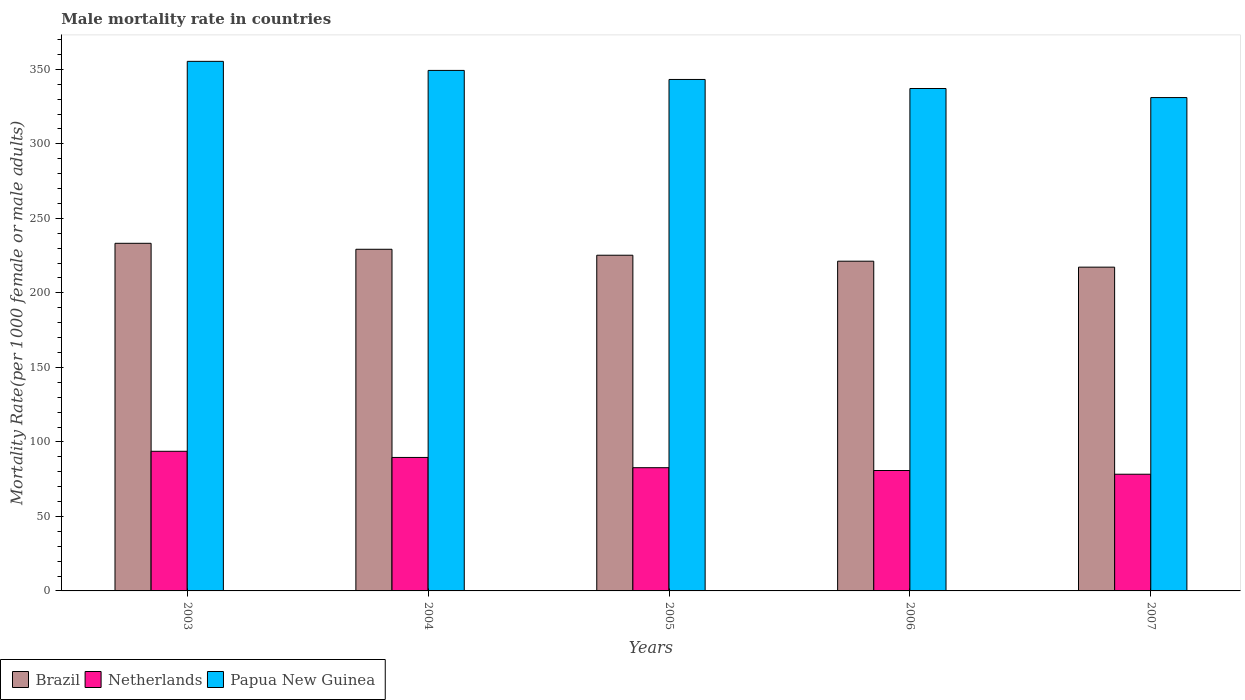How many bars are there on the 1st tick from the right?
Provide a short and direct response. 3. What is the label of the 1st group of bars from the left?
Give a very brief answer. 2003. What is the male mortality rate in Papua New Guinea in 2005?
Your answer should be very brief. 343.22. Across all years, what is the maximum male mortality rate in Papua New Guinea?
Provide a succinct answer. 355.37. Across all years, what is the minimum male mortality rate in Papua New Guinea?
Ensure brevity in your answer.  331.07. In which year was the male mortality rate in Papua New Guinea maximum?
Keep it short and to the point. 2003. What is the total male mortality rate in Netherlands in the graph?
Your response must be concise. 425.08. What is the difference between the male mortality rate in Brazil in 2004 and that in 2006?
Provide a short and direct response. 8. What is the difference between the male mortality rate in Papua New Guinea in 2007 and the male mortality rate in Brazil in 2006?
Your answer should be compact. 109.8. What is the average male mortality rate in Netherlands per year?
Provide a short and direct response. 85.02. In the year 2005, what is the difference between the male mortality rate in Netherlands and male mortality rate in Papua New Guinea?
Provide a succinct answer. -260.53. In how many years, is the male mortality rate in Papua New Guinea greater than 60?
Give a very brief answer. 5. What is the ratio of the male mortality rate in Brazil in 2003 to that in 2004?
Provide a succinct answer. 1.02. Is the male mortality rate in Brazil in 2003 less than that in 2005?
Offer a terse response. No. What is the difference between the highest and the second highest male mortality rate in Netherlands?
Make the answer very short. 4.14. What is the difference between the highest and the lowest male mortality rate in Netherlands?
Ensure brevity in your answer.  15.39. In how many years, is the male mortality rate in Netherlands greater than the average male mortality rate in Netherlands taken over all years?
Your response must be concise. 2. What does the 3rd bar from the left in 2004 represents?
Provide a short and direct response. Papua New Guinea. What does the 1st bar from the right in 2005 represents?
Offer a terse response. Papua New Guinea. Is it the case that in every year, the sum of the male mortality rate in Netherlands and male mortality rate in Brazil is greater than the male mortality rate in Papua New Guinea?
Provide a short and direct response. No. Are all the bars in the graph horizontal?
Give a very brief answer. No. How many years are there in the graph?
Your answer should be very brief. 5. What is the difference between two consecutive major ticks on the Y-axis?
Your answer should be compact. 50. Does the graph contain any zero values?
Ensure brevity in your answer.  No. Does the graph contain grids?
Provide a succinct answer. No. Where does the legend appear in the graph?
Your answer should be compact. Bottom left. What is the title of the graph?
Your response must be concise. Male mortality rate in countries. What is the label or title of the X-axis?
Provide a short and direct response. Years. What is the label or title of the Y-axis?
Keep it short and to the point. Mortality Rate(per 1000 female or male adults). What is the Mortality Rate(per 1000 female or male adults) of Brazil in 2003?
Ensure brevity in your answer.  233.27. What is the Mortality Rate(per 1000 female or male adults) of Netherlands in 2003?
Make the answer very short. 93.7. What is the Mortality Rate(per 1000 female or male adults) of Papua New Guinea in 2003?
Provide a succinct answer. 355.37. What is the Mortality Rate(per 1000 female or male adults) in Brazil in 2004?
Provide a short and direct response. 229.27. What is the Mortality Rate(per 1000 female or male adults) in Netherlands in 2004?
Give a very brief answer. 89.57. What is the Mortality Rate(per 1000 female or male adults) of Papua New Guinea in 2004?
Your response must be concise. 349.3. What is the Mortality Rate(per 1000 female or male adults) of Brazil in 2005?
Provide a short and direct response. 225.27. What is the Mortality Rate(per 1000 female or male adults) of Netherlands in 2005?
Offer a very short reply. 82.69. What is the Mortality Rate(per 1000 female or male adults) of Papua New Guinea in 2005?
Provide a short and direct response. 343.22. What is the Mortality Rate(per 1000 female or male adults) of Brazil in 2006?
Your response must be concise. 221.27. What is the Mortality Rate(per 1000 female or male adults) in Netherlands in 2006?
Your answer should be very brief. 80.8. What is the Mortality Rate(per 1000 female or male adults) of Papua New Guinea in 2006?
Offer a terse response. 337.14. What is the Mortality Rate(per 1000 female or male adults) of Brazil in 2007?
Your answer should be very brief. 217.27. What is the Mortality Rate(per 1000 female or male adults) of Netherlands in 2007?
Your answer should be very brief. 78.31. What is the Mortality Rate(per 1000 female or male adults) in Papua New Guinea in 2007?
Provide a short and direct response. 331.07. Across all years, what is the maximum Mortality Rate(per 1000 female or male adults) in Brazil?
Offer a terse response. 233.27. Across all years, what is the maximum Mortality Rate(per 1000 female or male adults) of Netherlands?
Your response must be concise. 93.7. Across all years, what is the maximum Mortality Rate(per 1000 female or male adults) in Papua New Guinea?
Your response must be concise. 355.37. Across all years, what is the minimum Mortality Rate(per 1000 female or male adults) of Brazil?
Offer a very short reply. 217.27. Across all years, what is the minimum Mortality Rate(per 1000 female or male adults) of Netherlands?
Give a very brief answer. 78.31. Across all years, what is the minimum Mortality Rate(per 1000 female or male adults) of Papua New Guinea?
Provide a succinct answer. 331.07. What is the total Mortality Rate(per 1000 female or male adults) of Brazil in the graph?
Provide a short and direct response. 1126.34. What is the total Mortality Rate(per 1000 female or male adults) in Netherlands in the graph?
Keep it short and to the point. 425.08. What is the total Mortality Rate(per 1000 female or male adults) in Papua New Guinea in the graph?
Provide a short and direct response. 1716.1. What is the difference between the Mortality Rate(per 1000 female or male adults) of Brazil in 2003 and that in 2004?
Your answer should be very brief. 4. What is the difference between the Mortality Rate(per 1000 female or male adults) in Netherlands in 2003 and that in 2004?
Provide a succinct answer. 4.14. What is the difference between the Mortality Rate(per 1000 female or male adults) in Papua New Guinea in 2003 and that in 2004?
Provide a succinct answer. 6.08. What is the difference between the Mortality Rate(per 1000 female or male adults) in Brazil in 2003 and that in 2005?
Your response must be concise. 8. What is the difference between the Mortality Rate(per 1000 female or male adults) in Netherlands in 2003 and that in 2005?
Provide a succinct answer. 11.01. What is the difference between the Mortality Rate(per 1000 female or male adults) of Papua New Guinea in 2003 and that in 2005?
Offer a very short reply. 12.15. What is the difference between the Mortality Rate(per 1000 female or male adults) in Brazil in 2003 and that in 2006?
Make the answer very short. 12. What is the difference between the Mortality Rate(per 1000 female or male adults) of Netherlands in 2003 and that in 2006?
Make the answer very short. 12.9. What is the difference between the Mortality Rate(per 1000 female or male adults) in Papua New Guinea in 2003 and that in 2006?
Ensure brevity in your answer.  18.23. What is the difference between the Mortality Rate(per 1000 female or male adults) of Brazil in 2003 and that in 2007?
Your answer should be very brief. 16. What is the difference between the Mortality Rate(per 1000 female or male adults) of Netherlands in 2003 and that in 2007?
Provide a succinct answer. 15.39. What is the difference between the Mortality Rate(per 1000 female or male adults) of Papua New Guinea in 2003 and that in 2007?
Provide a succinct answer. 24.3. What is the difference between the Mortality Rate(per 1000 female or male adults) in Brazil in 2004 and that in 2005?
Offer a very short reply. 4. What is the difference between the Mortality Rate(per 1000 female or male adults) in Netherlands in 2004 and that in 2005?
Your response must be concise. 6.87. What is the difference between the Mortality Rate(per 1000 female or male adults) in Papua New Guinea in 2004 and that in 2005?
Keep it short and to the point. 6.08. What is the difference between the Mortality Rate(per 1000 female or male adults) in Brazil in 2004 and that in 2006?
Give a very brief answer. 8. What is the difference between the Mortality Rate(per 1000 female or male adults) of Netherlands in 2004 and that in 2006?
Provide a succinct answer. 8.76. What is the difference between the Mortality Rate(per 1000 female or male adults) in Papua New Guinea in 2004 and that in 2006?
Ensure brevity in your answer.  12.15. What is the difference between the Mortality Rate(per 1000 female or male adults) of Brazil in 2004 and that in 2007?
Ensure brevity in your answer.  12. What is the difference between the Mortality Rate(per 1000 female or male adults) of Netherlands in 2004 and that in 2007?
Offer a very short reply. 11.25. What is the difference between the Mortality Rate(per 1000 female or male adults) of Papua New Guinea in 2004 and that in 2007?
Your answer should be compact. 18.23. What is the difference between the Mortality Rate(per 1000 female or male adults) in Brazil in 2005 and that in 2006?
Offer a terse response. 4. What is the difference between the Mortality Rate(per 1000 female or male adults) of Netherlands in 2005 and that in 2006?
Provide a short and direct response. 1.89. What is the difference between the Mortality Rate(per 1000 female or male adults) of Papua New Guinea in 2005 and that in 2006?
Ensure brevity in your answer.  6.08. What is the difference between the Mortality Rate(per 1000 female or male adults) of Netherlands in 2005 and that in 2007?
Provide a succinct answer. 4.38. What is the difference between the Mortality Rate(per 1000 female or male adults) of Papua New Guinea in 2005 and that in 2007?
Offer a very short reply. 12.15. What is the difference between the Mortality Rate(per 1000 female or male adults) of Brazil in 2006 and that in 2007?
Keep it short and to the point. 4. What is the difference between the Mortality Rate(per 1000 female or male adults) of Netherlands in 2006 and that in 2007?
Your answer should be very brief. 2.49. What is the difference between the Mortality Rate(per 1000 female or male adults) in Papua New Guinea in 2006 and that in 2007?
Give a very brief answer. 6.08. What is the difference between the Mortality Rate(per 1000 female or male adults) in Brazil in 2003 and the Mortality Rate(per 1000 female or male adults) in Netherlands in 2004?
Offer a terse response. 143.7. What is the difference between the Mortality Rate(per 1000 female or male adults) in Brazil in 2003 and the Mortality Rate(per 1000 female or male adults) in Papua New Guinea in 2004?
Give a very brief answer. -116.03. What is the difference between the Mortality Rate(per 1000 female or male adults) in Netherlands in 2003 and the Mortality Rate(per 1000 female or male adults) in Papua New Guinea in 2004?
Keep it short and to the point. -255.59. What is the difference between the Mortality Rate(per 1000 female or male adults) of Brazil in 2003 and the Mortality Rate(per 1000 female or male adults) of Netherlands in 2005?
Your answer should be very brief. 150.57. What is the difference between the Mortality Rate(per 1000 female or male adults) in Brazil in 2003 and the Mortality Rate(per 1000 female or male adults) in Papua New Guinea in 2005?
Keep it short and to the point. -109.95. What is the difference between the Mortality Rate(per 1000 female or male adults) of Netherlands in 2003 and the Mortality Rate(per 1000 female or male adults) of Papua New Guinea in 2005?
Your answer should be very brief. -249.52. What is the difference between the Mortality Rate(per 1000 female or male adults) of Brazil in 2003 and the Mortality Rate(per 1000 female or male adults) of Netherlands in 2006?
Your answer should be very brief. 152.47. What is the difference between the Mortality Rate(per 1000 female or male adults) in Brazil in 2003 and the Mortality Rate(per 1000 female or male adults) in Papua New Guinea in 2006?
Make the answer very short. -103.88. What is the difference between the Mortality Rate(per 1000 female or male adults) in Netherlands in 2003 and the Mortality Rate(per 1000 female or male adults) in Papua New Guinea in 2006?
Your response must be concise. -243.44. What is the difference between the Mortality Rate(per 1000 female or male adults) in Brazil in 2003 and the Mortality Rate(per 1000 female or male adults) in Netherlands in 2007?
Provide a short and direct response. 154.95. What is the difference between the Mortality Rate(per 1000 female or male adults) of Brazil in 2003 and the Mortality Rate(per 1000 female or male adults) of Papua New Guinea in 2007?
Keep it short and to the point. -97.8. What is the difference between the Mortality Rate(per 1000 female or male adults) of Netherlands in 2003 and the Mortality Rate(per 1000 female or male adults) of Papua New Guinea in 2007?
Keep it short and to the point. -237.37. What is the difference between the Mortality Rate(per 1000 female or male adults) of Brazil in 2004 and the Mortality Rate(per 1000 female or male adults) of Netherlands in 2005?
Your response must be concise. 146.57. What is the difference between the Mortality Rate(per 1000 female or male adults) of Brazil in 2004 and the Mortality Rate(per 1000 female or male adults) of Papua New Guinea in 2005?
Make the answer very short. -113.95. What is the difference between the Mortality Rate(per 1000 female or male adults) in Netherlands in 2004 and the Mortality Rate(per 1000 female or male adults) in Papua New Guinea in 2005?
Provide a short and direct response. -253.66. What is the difference between the Mortality Rate(per 1000 female or male adults) of Brazil in 2004 and the Mortality Rate(per 1000 female or male adults) of Netherlands in 2006?
Provide a succinct answer. 148.47. What is the difference between the Mortality Rate(per 1000 female or male adults) in Brazil in 2004 and the Mortality Rate(per 1000 female or male adults) in Papua New Guinea in 2006?
Provide a succinct answer. -107.88. What is the difference between the Mortality Rate(per 1000 female or male adults) of Netherlands in 2004 and the Mortality Rate(per 1000 female or male adults) of Papua New Guinea in 2006?
Offer a very short reply. -247.58. What is the difference between the Mortality Rate(per 1000 female or male adults) in Brazil in 2004 and the Mortality Rate(per 1000 female or male adults) in Netherlands in 2007?
Give a very brief answer. 150.95. What is the difference between the Mortality Rate(per 1000 female or male adults) of Brazil in 2004 and the Mortality Rate(per 1000 female or male adults) of Papua New Guinea in 2007?
Your answer should be very brief. -101.8. What is the difference between the Mortality Rate(per 1000 female or male adults) in Netherlands in 2004 and the Mortality Rate(per 1000 female or male adults) in Papua New Guinea in 2007?
Keep it short and to the point. -241.5. What is the difference between the Mortality Rate(per 1000 female or male adults) of Brazil in 2005 and the Mortality Rate(per 1000 female or male adults) of Netherlands in 2006?
Your response must be concise. 144.47. What is the difference between the Mortality Rate(per 1000 female or male adults) in Brazil in 2005 and the Mortality Rate(per 1000 female or male adults) in Papua New Guinea in 2006?
Ensure brevity in your answer.  -111.88. What is the difference between the Mortality Rate(per 1000 female or male adults) of Netherlands in 2005 and the Mortality Rate(per 1000 female or male adults) of Papua New Guinea in 2006?
Ensure brevity in your answer.  -254.45. What is the difference between the Mortality Rate(per 1000 female or male adults) of Brazil in 2005 and the Mortality Rate(per 1000 female or male adults) of Netherlands in 2007?
Your response must be concise. 146.95. What is the difference between the Mortality Rate(per 1000 female or male adults) in Brazil in 2005 and the Mortality Rate(per 1000 female or male adults) in Papua New Guinea in 2007?
Your answer should be very brief. -105.8. What is the difference between the Mortality Rate(per 1000 female or male adults) in Netherlands in 2005 and the Mortality Rate(per 1000 female or male adults) in Papua New Guinea in 2007?
Provide a short and direct response. -248.38. What is the difference between the Mortality Rate(per 1000 female or male adults) in Brazil in 2006 and the Mortality Rate(per 1000 female or male adults) in Netherlands in 2007?
Ensure brevity in your answer.  142.95. What is the difference between the Mortality Rate(per 1000 female or male adults) in Brazil in 2006 and the Mortality Rate(per 1000 female or male adults) in Papua New Guinea in 2007?
Your response must be concise. -109.8. What is the difference between the Mortality Rate(per 1000 female or male adults) of Netherlands in 2006 and the Mortality Rate(per 1000 female or male adults) of Papua New Guinea in 2007?
Ensure brevity in your answer.  -250.27. What is the average Mortality Rate(per 1000 female or male adults) in Brazil per year?
Your answer should be very brief. 225.27. What is the average Mortality Rate(per 1000 female or male adults) in Netherlands per year?
Provide a succinct answer. 85.02. What is the average Mortality Rate(per 1000 female or male adults) in Papua New Guinea per year?
Make the answer very short. 343.22. In the year 2003, what is the difference between the Mortality Rate(per 1000 female or male adults) in Brazil and Mortality Rate(per 1000 female or male adults) in Netherlands?
Offer a terse response. 139.56. In the year 2003, what is the difference between the Mortality Rate(per 1000 female or male adults) of Brazil and Mortality Rate(per 1000 female or male adults) of Papua New Guinea?
Provide a short and direct response. -122.11. In the year 2003, what is the difference between the Mortality Rate(per 1000 female or male adults) of Netherlands and Mortality Rate(per 1000 female or male adults) of Papua New Guinea?
Your answer should be very brief. -261.67. In the year 2004, what is the difference between the Mortality Rate(per 1000 female or male adults) in Brazil and Mortality Rate(per 1000 female or male adults) in Netherlands?
Give a very brief answer. 139.7. In the year 2004, what is the difference between the Mortality Rate(per 1000 female or male adults) in Brazil and Mortality Rate(per 1000 female or male adults) in Papua New Guinea?
Ensure brevity in your answer.  -120.03. In the year 2004, what is the difference between the Mortality Rate(per 1000 female or male adults) of Netherlands and Mortality Rate(per 1000 female or male adults) of Papua New Guinea?
Make the answer very short. -259.73. In the year 2005, what is the difference between the Mortality Rate(per 1000 female or male adults) of Brazil and Mortality Rate(per 1000 female or male adults) of Netherlands?
Make the answer very short. 142.57. In the year 2005, what is the difference between the Mortality Rate(per 1000 female or male adults) in Brazil and Mortality Rate(per 1000 female or male adults) in Papua New Guinea?
Offer a terse response. -117.95. In the year 2005, what is the difference between the Mortality Rate(per 1000 female or male adults) in Netherlands and Mortality Rate(per 1000 female or male adults) in Papua New Guinea?
Provide a short and direct response. -260.53. In the year 2006, what is the difference between the Mortality Rate(per 1000 female or male adults) of Brazil and Mortality Rate(per 1000 female or male adults) of Netherlands?
Your answer should be very brief. 140.47. In the year 2006, what is the difference between the Mortality Rate(per 1000 female or male adults) of Brazil and Mortality Rate(per 1000 female or male adults) of Papua New Guinea?
Offer a very short reply. -115.88. In the year 2006, what is the difference between the Mortality Rate(per 1000 female or male adults) in Netherlands and Mortality Rate(per 1000 female or male adults) in Papua New Guinea?
Make the answer very short. -256.34. In the year 2007, what is the difference between the Mortality Rate(per 1000 female or male adults) in Brazil and Mortality Rate(per 1000 female or male adults) in Netherlands?
Keep it short and to the point. 138.95. In the year 2007, what is the difference between the Mortality Rate(per 1000 female or male adults) in Brazil and Mortality Rate(per 1000 female or male adults) in Papua New Guinea?
Your response must be concise. -113.8. In the year 2007, what is the difference between the Mortality Rate(per 1000 female or male adults) of Netherlands and Mortality Rate(per 1000 female or male adults) of Papua New Guinea?
Keep it short and to the point. -252.76. What is the ratio of the Mortality Rate(per 1000 female or male adults) in Brazil in 2003 to that in 2004?
Make the answer very short. 1.02. What is the ratio of the Mortality Rate(per 1000 female or male adults) in Netherlands in 2003 to that in 2004?
Provide a short and direct response. 1.05. What is the ratio of the Mortality Rate(per 1000 female or male adults) in Papua New Guinea in 2003 to that in 2004?
Your answer should be compact. 1.02. What is the ratio of the Mortality Rate(per 1000 female or male adults) of Brazil in 2003 to that in 2005?
Offer a very short reply. 1.04. What is the ratio of the Mortality Rate(per 1000 female or male adults) in Netherlands in 2003 to that in 2005?
Your response must be concise. 1.13. What is the ratio of the Mortality Rate(per 1000 female or male adults) in Papua New Guinea in 2003 to that in 2005?
Offer a terse response. 1.04. What is the ratio of the Mortality Rate(per 1000 female or male adults) of Brazil in 2003 to that in 2006?
Your response must be concise. 1.05. What is the ratio of the Mortality Rate(per 1000 female or male adults) in Netherlands in 2003 to that in 2006?
Your answer should be compact. 1.16. What is the ratio of the Mortality Rate(per 1000 female or male adults) of Papua New Guinea in 2003 to that in 2006?
Your answer should be compact. 1.05. What is the ratio of the Mortality Rate(per 1000 female or male adults) of Brazil in 2003 to that in 2007?
Offer a very short reply. 1.07. What is the ratio of the Mortality Rate(per 1000 female or male adults) in Netherlands in 2003 to that in 2007?
Give a very brief answer. 1.2. What is the ratio of the Mortality Rate(per 1000 female or male adults) of Papua New Guinea in 2003 to that in 2007?
Ensure brevity in your answer.  1.07. What is the ratio of the Mortality Rate(per 1000 female or male adults) of Brazil in 2004 to that in 2005?
Offer a very short reply. 1.02. What is the ratio of the Mortality Rate(per 1000 female or male adults) in Netherlands in 2004 to that in 2005?
Make the answer very short. 1.08. What is the ratio of the Mortality Rate(per 1000 female or male adults) in Papua New Guinea in 2004 to that in 2005?
Make the answer very short. 1.02. What is the ratio of the Mortality Rate(per 1000 female or male adults) of Brazil in 2004 to that in 2006?
Keep it short and to the point. 1.04. What is the ratio of the Mortality Rate(per 1000 female or male adults) in Netherlands in 2004 to that in 2006?
Offer a very short reply. 1.11. What is the ratio of the Mortality Rate(per 1000 female or male adults) of Papua New Guinea in 2004 to that in 2006?
Provide a short and direct response. 1.04. What is the ratio of the Mortality Rate(per 1000 female or male adults) in Brazil in 2004 to that in 2007?
Your answer should be very brief. 1.06. What is the ratio of the Mortality Rate(per 1000 female or male adults) in Netherlands in 2004 to that in 2007?
Give a very brief answer. 1.14. What is the ratio of the Mortality Rate(per 1000 female or male adults) of Papua New Guinea in 2004 to that in 2007?
Provide a succinct answer. 1.06. What is the ratio of the Mortality Rate(per 1000 female or male adults) of Brazil in 2005 to that in 2006?
Ensure brevity in your answer.  1.02. What is the ratio of the Mortality Rate(per 1000 female or male adults) of Netherlands in 2005 to that in 2006?
Your answer should be very brief. 1.02. What is the ratio of the Mortality Rate(per 1000 female or male adults) of Brazil in 2005 to that in 2007?
Give a very brief answer. 1.04. What is the ratio of the Mortality Rate(per 1000 female or male adults) in Netherlands in 2005 to that in 2007?
Keep it short and to the point. 1.06. What is the ratio of the Mortality Rate(per 1000 female or male adults) of Papua New Guinea in 2005 to that in 2007?
Provide a succinct answer. 1.04. What is the ratio of the Mortality Rate(per 1000 female or male adults) of Brazil in 2006 to that in 2007?
Make the answer very short. 1.02. What is the ratio of the Mortality Rate(per 1000 female or male adults) in Netherlands in 2006 to that in 2007?
Offer a very short reply. 1.03. What is the ratio of the Mortality Rate(per 1000 female or male adults) in Papua New Guinea in 2006 to that in 2007?
Ensure brevity in your answer.  1.02. What is the difference between the highest and the second highest Mortality Rate(per 1000 female or male adults) in Brazil?
Provide a short and direct response. 4. What is the difference between the highest and the second highest Mortality Rate(per 1000 female or male adults) of Netherlands?
Your answer should be compact. 4.14. What is the difference between the highest and the second highest Mortality Rate(per 1000 female or male adults) of Papua New Guinea?
Make the answer very short. 6.08. What is the difference between the highest and the lowest Mortality Rate(per 1000 female or male adults) of Brazil?
Your response must be concise. 16. What is the difference between the highest and the lowest Mortality Rate(per 1000 female or male adults) of Netherlands?
Your response must be concise. 15.39. What is the difference between the highest and the lowest Mortality Rate(per 1000 female or male adults) in Papua New Guinea?
Your response must be concise. 24.3. 